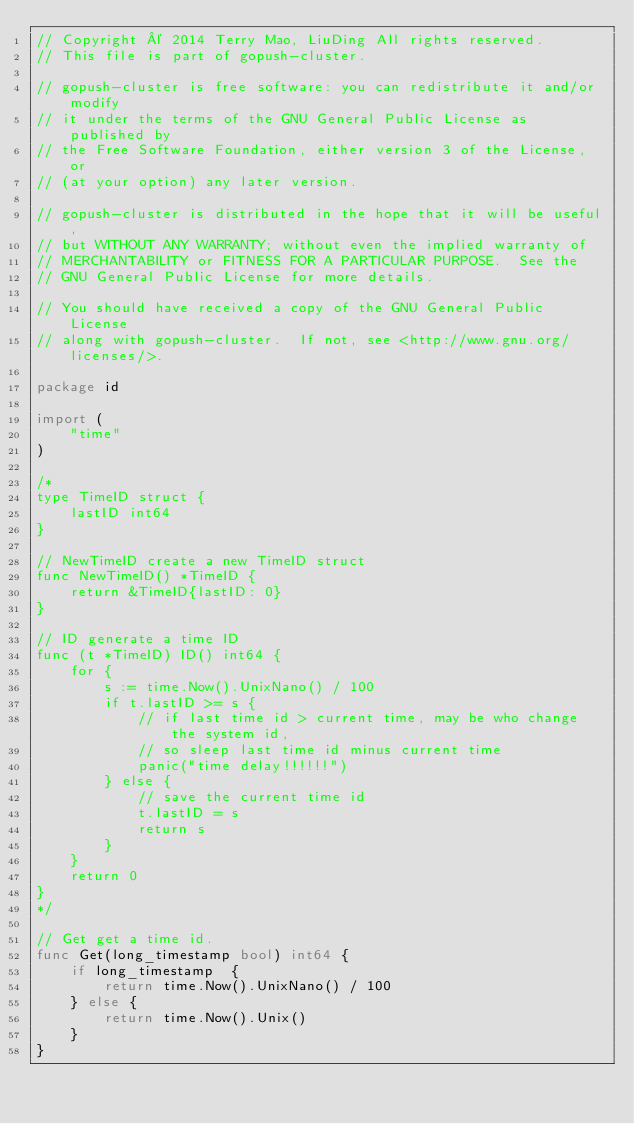Convert code to text. <code><loc_0><loc_0><loc_500><loc_500><_Go_>// Copyright © 2014 Terry Mao, LiuDing All rights reserved.
// This file is part of gopush-cluster.

// gopush-cluster is free software: you can redistribute it and/or modify
// it under the terms of the GNU General Public License as published by
// the Free Software Foundation, either version 3 of the License, or
// (at your option) any later version.

// gopush-cluster is distributed in the hope that it will be useful,
// but WITHOUT ANY WARRANTY; without even the implied warranty of
// MERCHANTABILITY or FITNESS FOR A PARTICULAR PURPOSE.  See the
// GNU General Public License for more details.

// You should have received a copy of the GNU General Public License
// along with gopush-cluster.  If not, see <http://www.gnu.org/licenses/>.

package id

import (
	"time"
)

/*
type TimeID struct {
	lastID int64
}

// NewTimeID create a new TimeID struct
func NewTimeID() *TimeID {
	return &TimeID{lastID: 0}
}

// ID generate a time ID
func (t *TimeID) ID() int64 {
	for {
		s := time.Now().UnixNano() / 100
		if t.lastID >= s {
			// if last time id > current time, may be who change the system id,
			// so sleep last time id minus current time
			panic("time delay!!!!!!")
		} else {
			// save the current time id
			t.lastID = s
			return s
		}
	}
	return 0
}
*/

// Get get a time id.
func Get(long_timestamp bool) int64 {
	if long_timestamp  {
		return time.Now().UnixNano() / 100
	} else {
		return time.Now().Unix() 
	}
}
</code> 